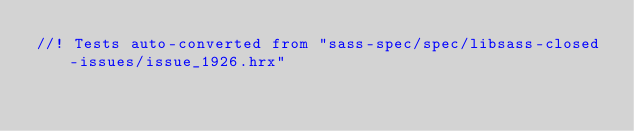<code> <loc_0><loc_0><loc_500><loc_500><_Rust_>//! Tests auto-converted from "sass-spec/spec/libsass-closed-issues/issue_1926.hrx"
</code> 